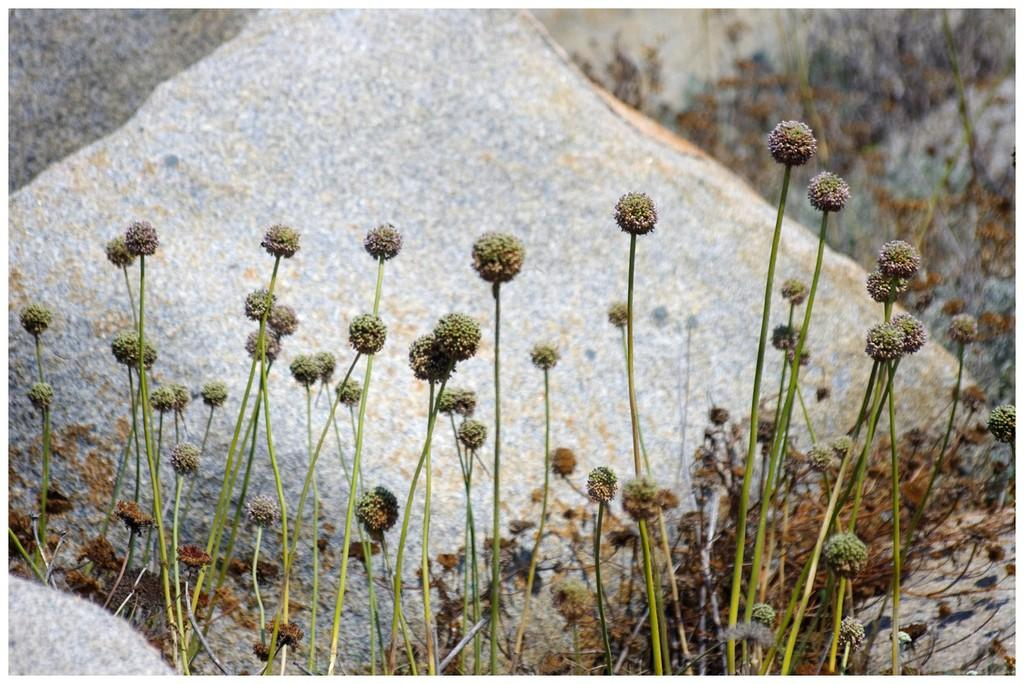What type of living organisms can be seen in the image? Plants can be seen in the image. What other objects are present in the image besides plants? There are rocks in the image. What is the tongue's role in the image? There is no tongue present in the image. 